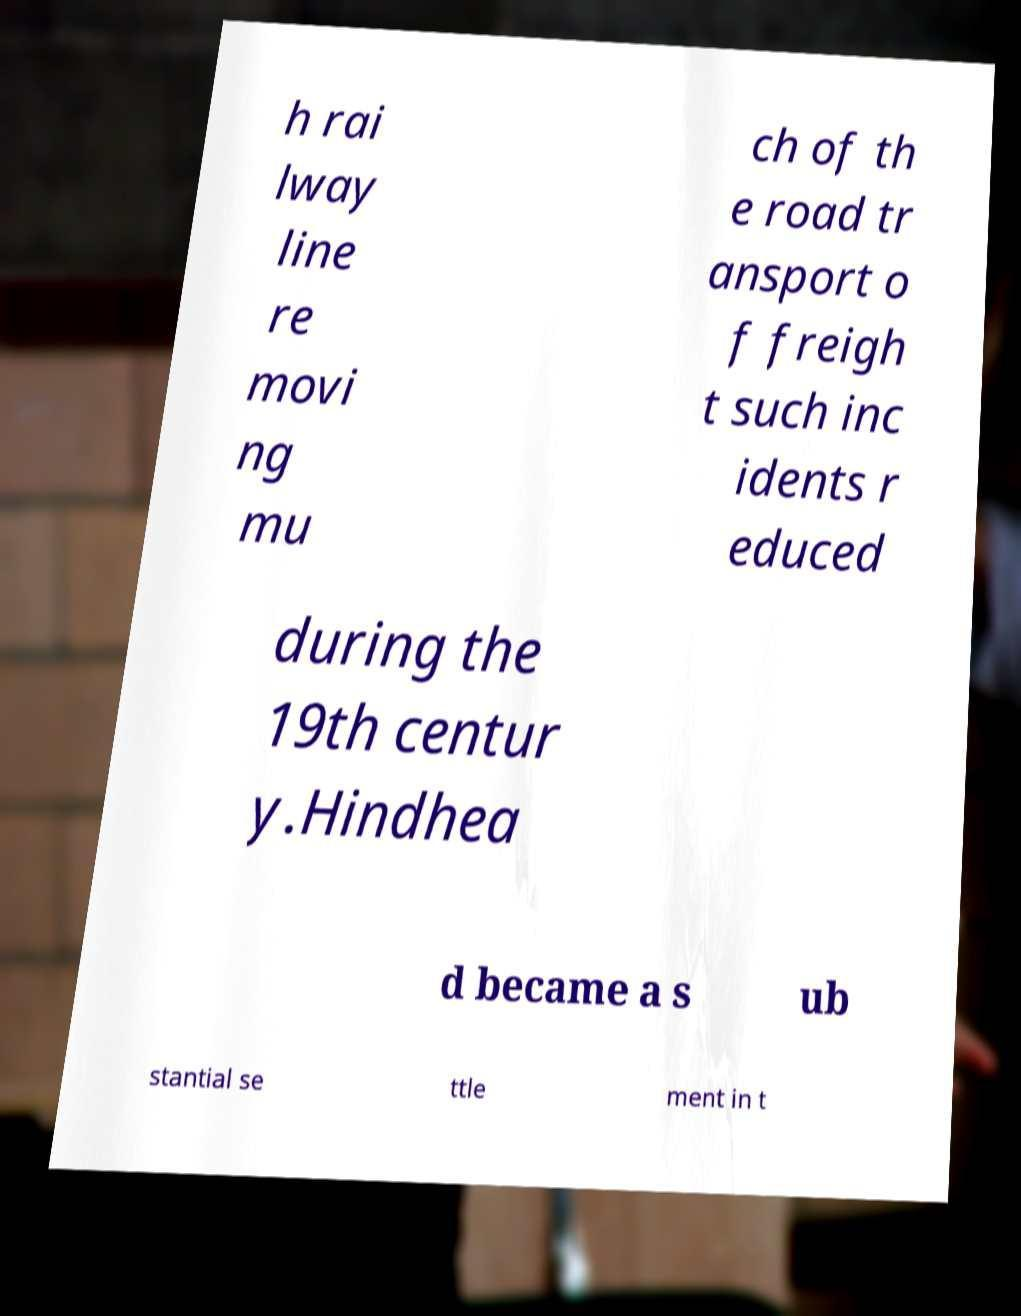For documentation purposes, I need the text within this image transcribed. Could you provide that? h rai lway line re movi ng mu ch of th e road tr ansport o f freigh t such inc idents r educed during the 19th centur y.Hindhea d became a s ub stantial se ttle ment in t 